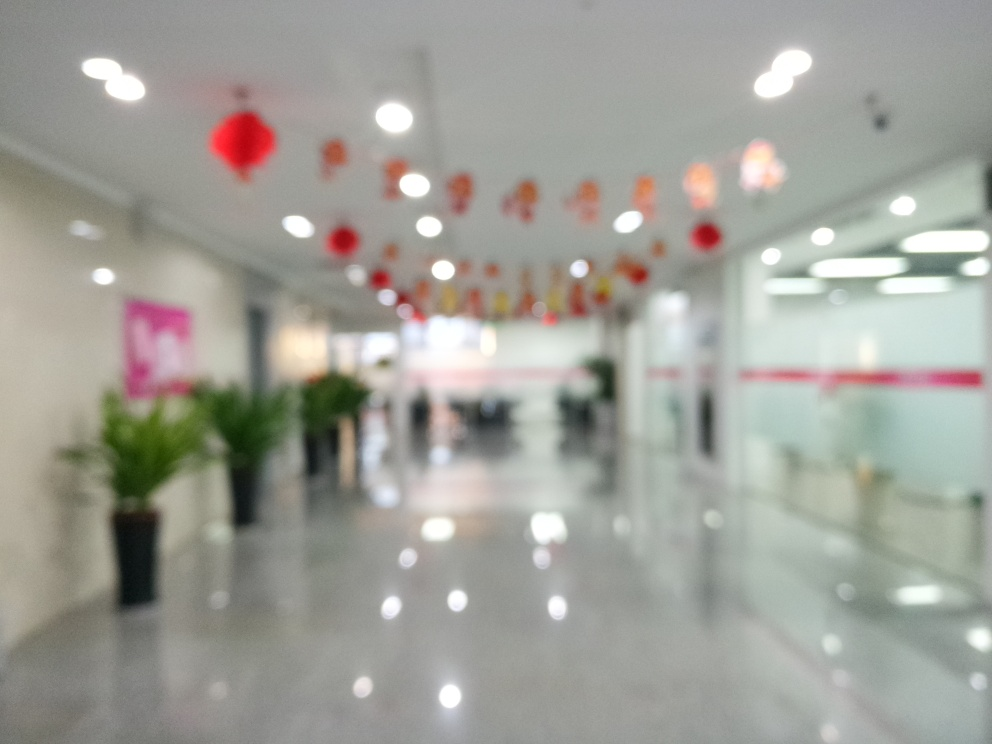Can you describe the overall ambiance of the space depicted in the image? The image conveys a blurred interior space, possibly a hallway or lobby, which creates a sense of activity and movement. The presence of decorations, like the red lanterns, suggests a festive or celebratory atmosphere, potentially aligning with a cultural event or holiday. 